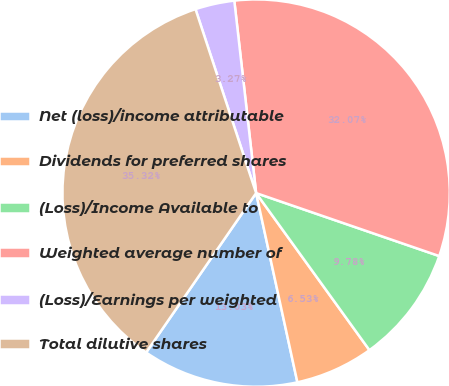Convert chart. <chart><loc_0><loc_0><loc_500><loc_500><pie_chart><fcel>Net (loss)/income attributable<fcel>Dividends for preferred shares<fcel>(Loss)/Income Available to<fcel>Weighted average number of<fcel>(Loss)/Earnings per weighted<fcel>Total dilutive shares<nl><fcel>13.03%<fcel>6.53%<fcel>9.78%<fcel>32.07%<fcel>3.27%<fcel>35.32%<nl></chart> 